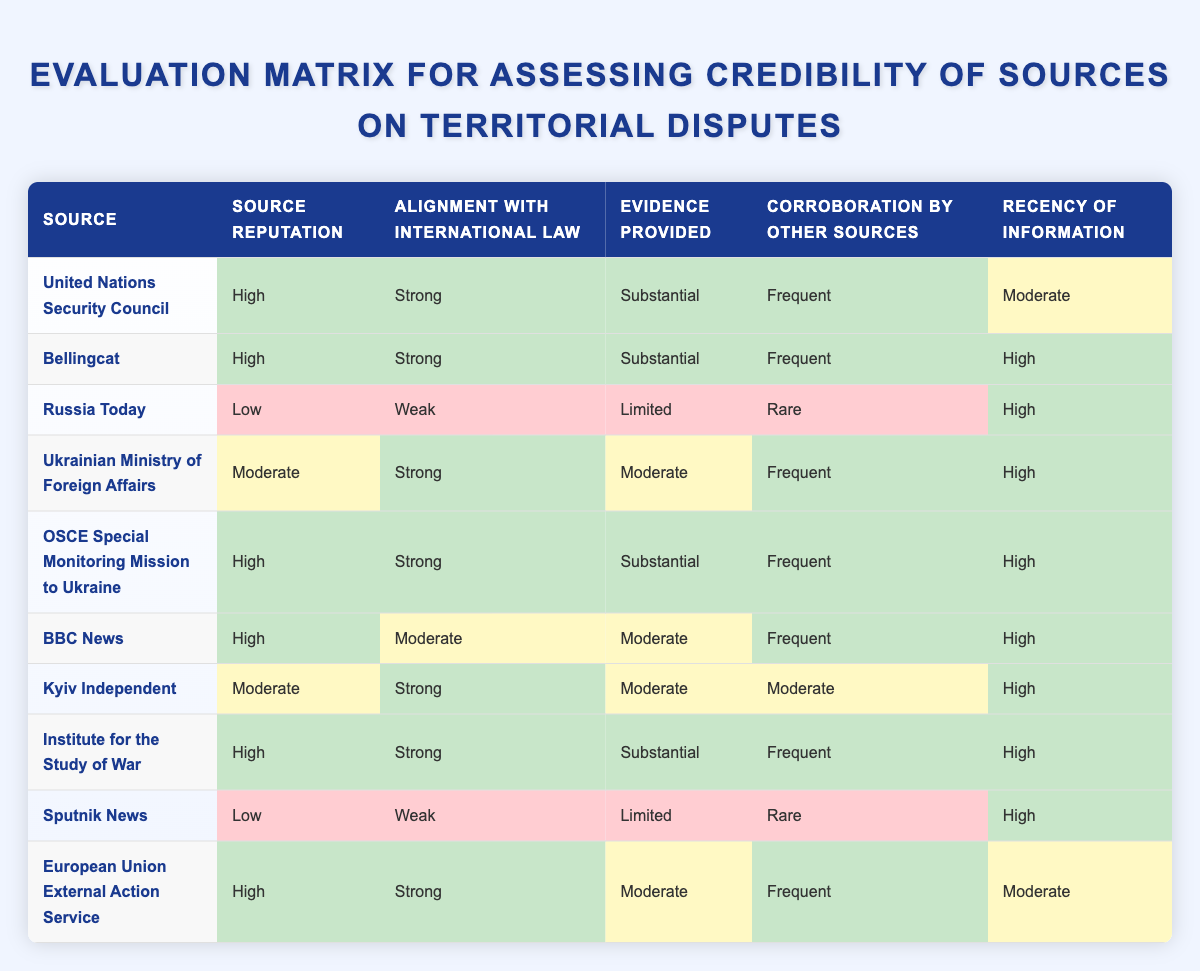What is the source with the lowest reputation? To find the source with the lowest reputation, I look for the cell under "Source Reputation" that indicates "Low." In the evaluations, Russia Today and Sputnik News both have this rating. However, the first one I encounter in the table is Russia Today.
Answer: Russia Today Which sources have a strong alignment with international law? To identify the sources with a strong alignment with international law, I scan the "Alignment with International Law" column for "Strong." The sources that meet this criterion are: United Nations Security Council, Bellingcat, Ukrainian Ministry of Foreign Affairs, OSCE Special Monitoring Mission to Ukraine, Institute for the Study of War, Kyiv Independent, and European Union External Action Service.
Answer: United Nations Security Council, Bellingcat, Ukrainian Ministry of Foreign Affairs, OSCE Special Monitoring Mission to Ukraine, Institute for the Study of War, Kyiv Independent, European Union External Action Service How many sources provide substantial evidence? I look through the "Evidence Provided" column for the count of entries labeled "Substantial." The sources providing substantial evidence are: United Nations Security Council, Bellingcat, OSCE Special Monitoring Mission to Ukraine, Institute for the Study of War. There are four sources in total.
Answer: 4 Is the information from BBC News recent? I check the "Recency of Information" for BBC News and find it indicates "High." Therefore, the information from BBC News is indeed recent.
Answer: Yes Do both Russia Today and Sputnik News have frequent corroboration from other sources? Under the "Corroboration by Other Sources" column, Russia Today is marked as "Rare" and Sputnik News is also marked as "Rare." Since neither has "Frequent," the statement is false.
Answer: No Which source has both high reputation and high recency of information? I look for entries in the "Source Reputation" that are labeled "High" and also have "High" in the "Recency of Information" column. The sources that meet these criteria are: Bellingcat, OSCE Special Monitoring Mission to Ukraine, BBC News, Institute for the Study of War. This indicates multiple sources meet the condition, demonstrating the quality of information they provide.
Answer: Bellingcat, OSCE Special Monitoring Mission to Ukraine, BBC News, Institute for the Study of War What is the average reputation level of the sources listed? The reputations can be categorized as High (3), Moderate (2), and Low (1). The data includes: UN Security Council (3), Bellingcat (3), Russia Today (1), Ukrainian Ministry of Foreign Affairs (2), OSCE (3), BBC News (3), Kyiv Independent (2), Institute for the Study of War (3), Sputnik News (1), and EU External Action Service (3). To calculate the average: (3+3+1+2+3+3+2+3+1+3)=22; there are 10 sources giving us 22/10=2.2, which corresponds to between Moderate and High.
Answer: Approximately Moderate Which source is aligned with international law but has a low reputation? I look for “Strong” under "Alignment with International Law" and “Low” under "Source Reputation." No sources match this criterion simultaneously, as the only low reputation sources (Russia Today and Sputnik News) do not have a strong alignment with international law.
Answer: None 